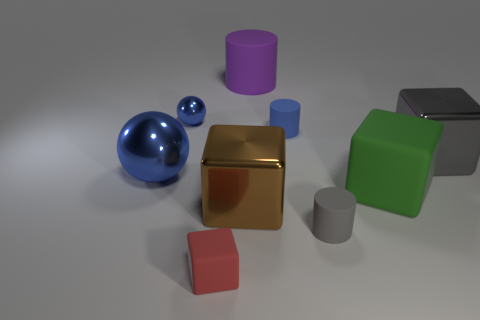Is the number of small blue metal things in front of the large green cube less than the number of large objects?
Offer a terse response. Yes. There is a tiny blue thing that is on the right side of the purple rubber object; what is its material?
Provide a succinct answer. Rubber. How many other objects are the same size as the purple rubber object?
Offer a terse response. 4. There is a gray metallic block; is it the same size as the blue object that is right of the red cube?
Your answer should be compact. No. There is a blue object on the right side of the small matte object that is to the left of the large object that is in front of the green rubber block; what shape is it?
Your answer should be very brief. Cylinder. Is the number of blocks less than the number of rubber cylinders?
Offer a very short reply. No. There is a brown object; are there any shiny cubes behind it?
Give a very brief answer. Yes. What is the shape of the tiny thing that is in front of the small blue metal ball and behind the green rubber block?
Ensure brevity in your answer.  Cylinder. Are there any tiny red rubber objects that have the same shape as the large purple matte thing?
Give a very brief answer. No. There is a cube that is behind the green object; is it the same size as the brown cube on the left side of the large green matte cube?
Your answer should be compact. Yes. 